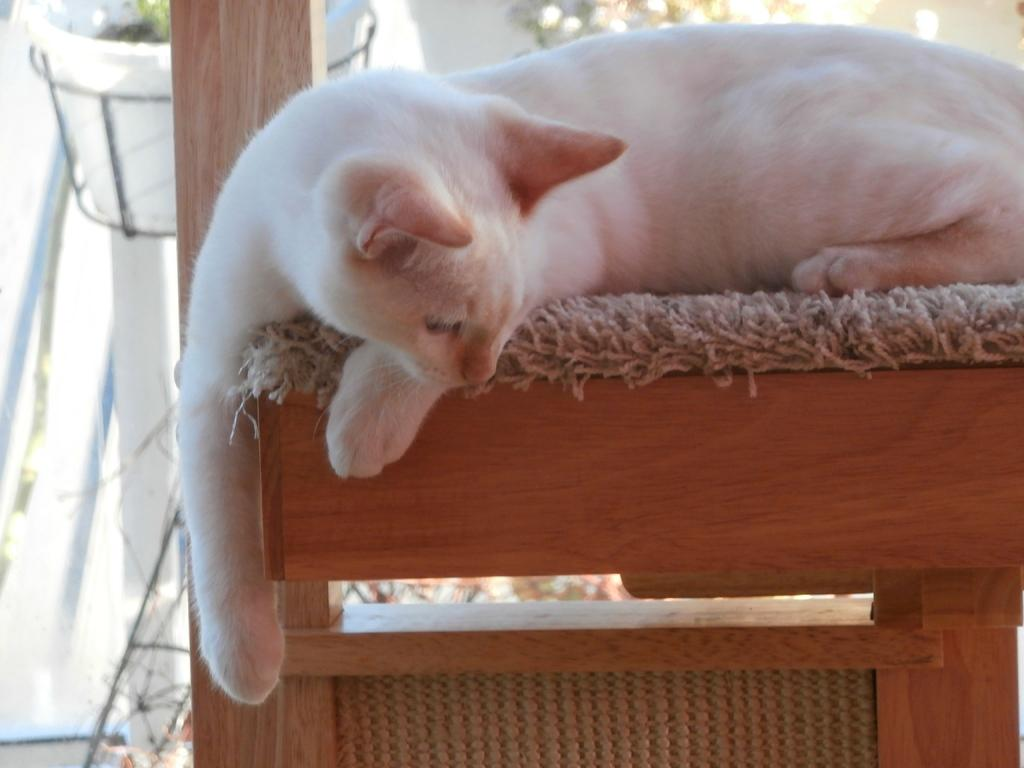What type of animal is in the image? There is a white cat in the image. What is the cat laying on? The cat is laying on a cloth. What type of material can be seen in the image? There are wooden pieces in the image. What can be seen in the background of the image? There is a pot and a grill in the background of the image. What is the daughter doing in the alley in the image? There is no daughter or alley present in the image; it features a white cat laying on a cloth, wooden pieces, and a background with a pot and a grill. 